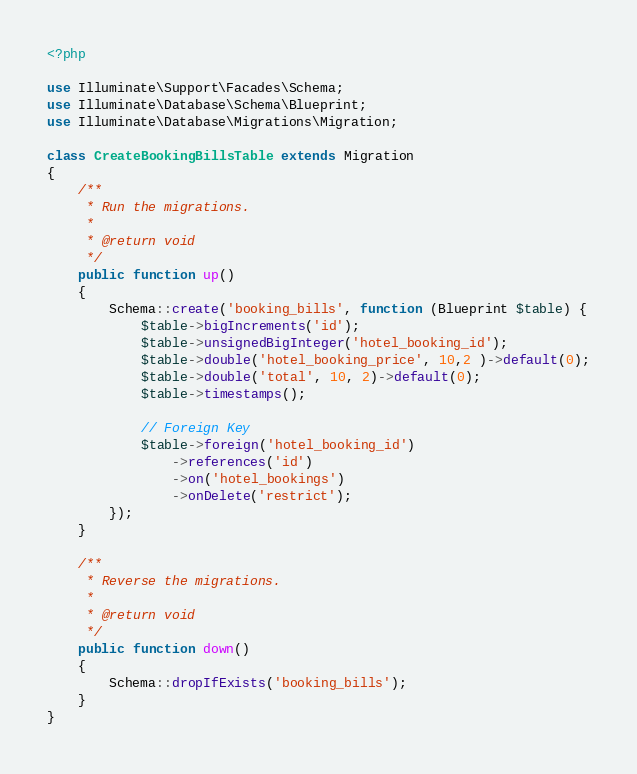Convert code to text. <code><loc_0><loc_0><loc_500><loc_500><_PHP_><?php

use Illuminate\Support\Facades\Schema;
use Illuminate\Database\Schema\Blueprint;
use Illuminate\Database\Migrations\Migration;

class CreateBookingBillsTable extends Migration
{
    /**
     * Run the migrations.
     *
     * @return void
     */
    public function up()
    {
        Schema::create('booking_bills', function (Blueprint $table) {
            $table->bigIncrements('id');
            $table->unsignedBigInteger('hotel_booking_id');
            $table->double('hotel_booking_price', 10,2 )->default(0);
            $table->double('total', 10, 2)->default(0);
            $table->timestamps();

            // Foreign Key
            $table->foreign('hotel_booking_id')
                ->references('id')
                ->on('hotel_bookings')
                ->onDelete('restrict');
        });
    }

    /**
     * Reverse the migrations.
     *
     * @return void
     */
    public function down()
    {
        Schema::dropIfExists('booking_bills');
    }
}
</code> 